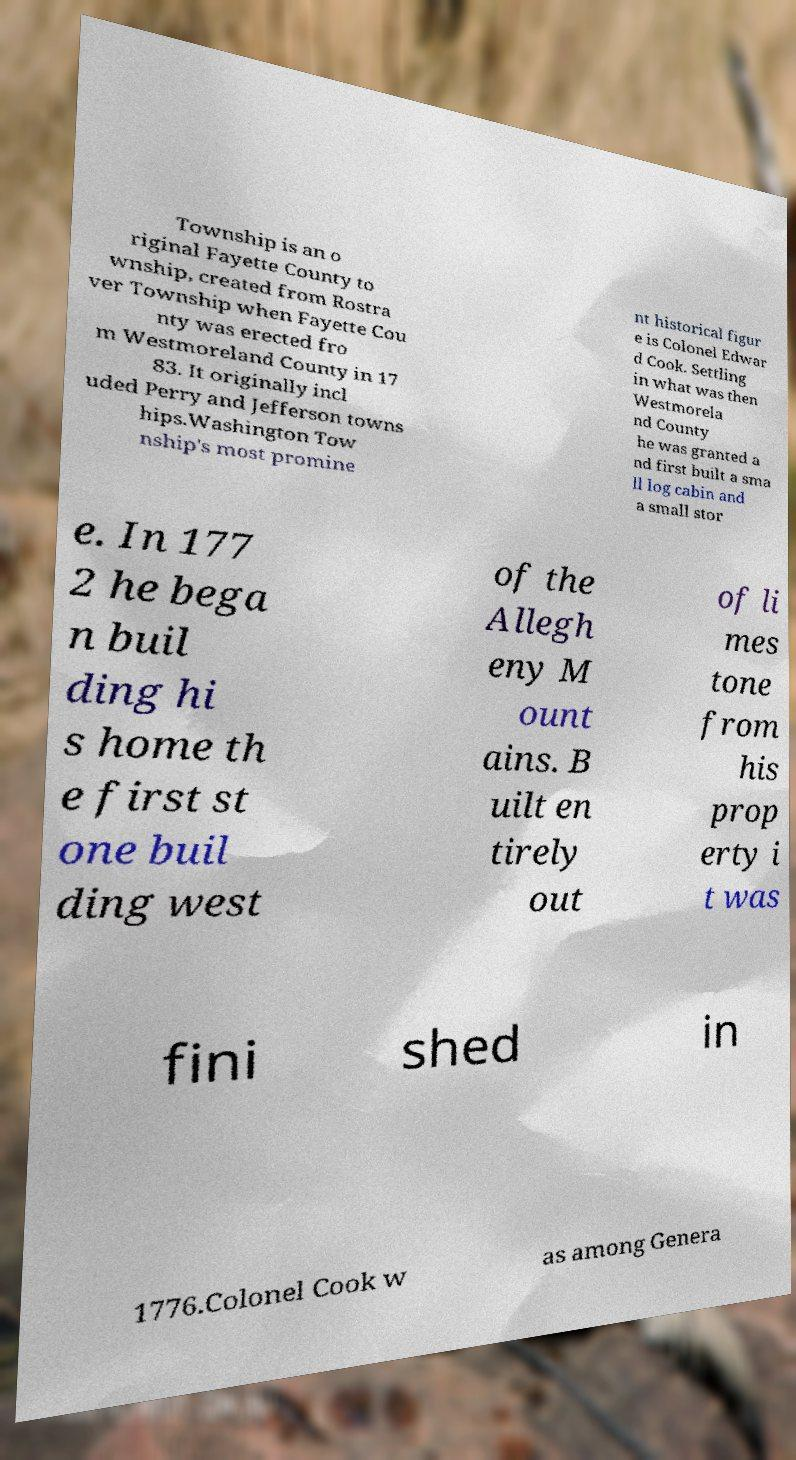What messages or text are displayed in this image? I need them in a readable, typed format. Township is an o riginal Fayette County to wnship, created from Rostra ver Township when Fayette Cou nty was erected fro m Westmoreland County in 17 83. It originally incl uded Perry and Jefferson towns hips.Washington Tow nship's most promine nt historical figur e is Colonel Edwar d Cook. Settling in what was then Westmorela nd County he was granted a nd first built a sma ll log cabin and a small stor e. In 177 2 he bega n buil ding hi s home th e first st one buil ding west of the Allegh eny M ount ains. B uilt en tirely out of li mes tone from his prop erty i t was fini shed in 1776.Colonel Cook w as among Genera 